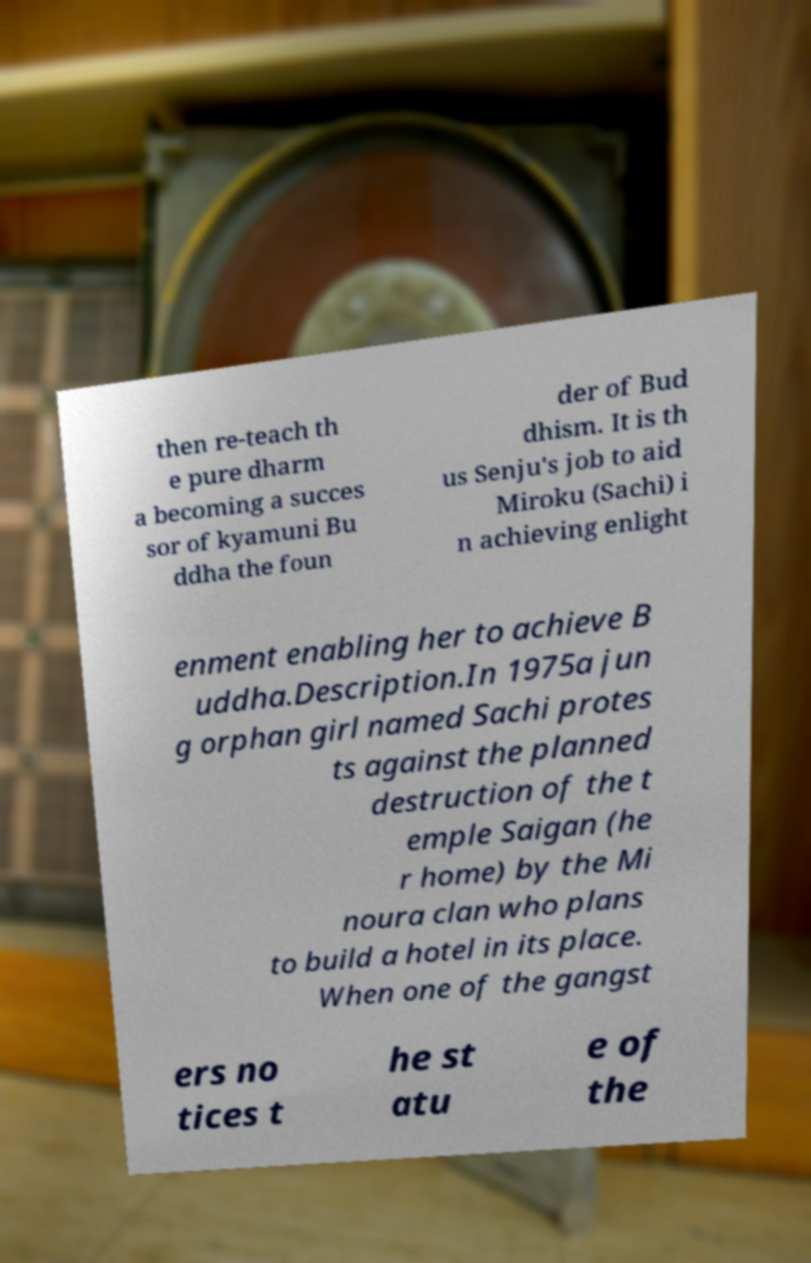Could you assist in decoding the text presented in this image and type it out clearly? then re-teach th e pure dharm a becoming a succes sor of kyamuni Bu ddha the foun der of Bud dhism. It is th us Senju's job to aid Miroku (Sachi) i n achieving enlight enment enabling her to achieve B uddha.Description.In 1975a jun g orphan girl named Sachi protes ts against the planned destruction of the t emple Saigan (he r home) by the Mi noura clan who plans to build a hotel in its place. When one of the gangst ers no tices t he st atu e of the 